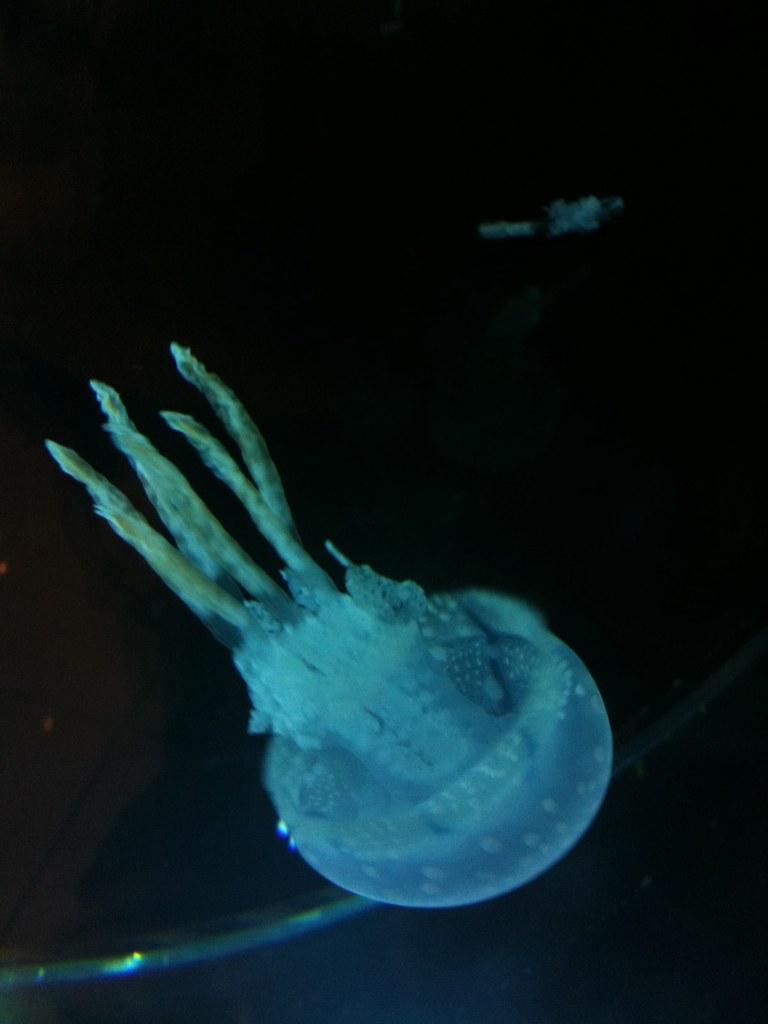Describe this image in one or two sentences. In this image I can see the jellyfish and there is a black background. 